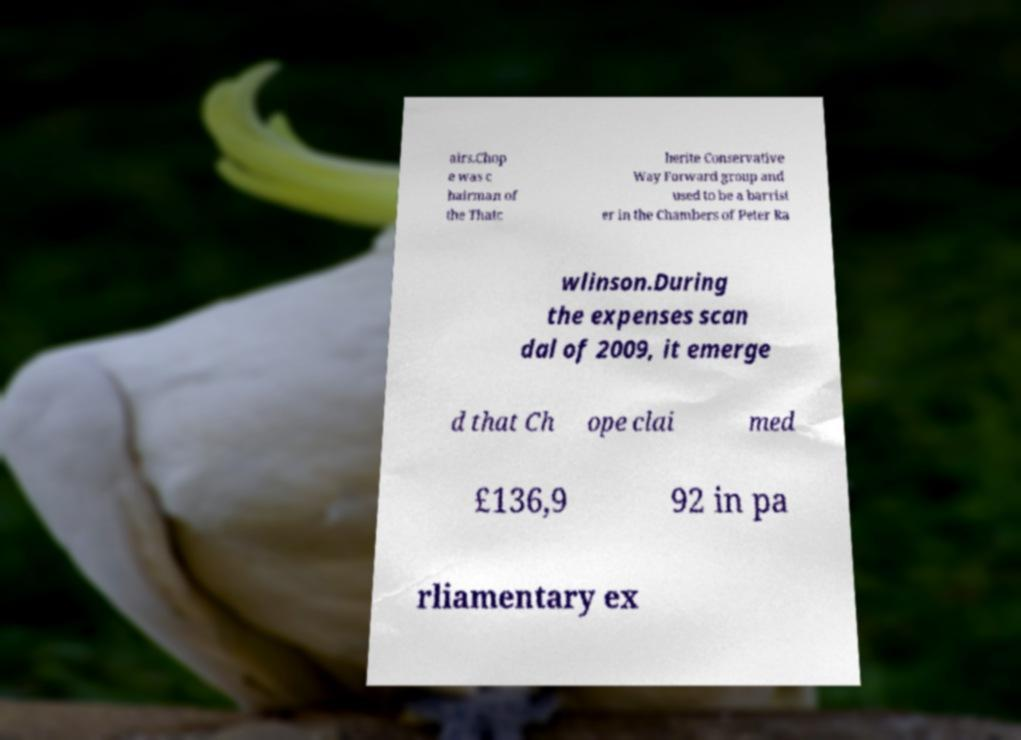Could you extract and type out the text from this image? airs.Chop e was c hairman of the Thatc herite Conservative Way Forward group and used to be a barrist er in the Chambers of Peter Ra wlinson.During the expenses scan dal of 2009, it emerge d that Ch ope clai med £136,9 92 in pa rliamentary ex 